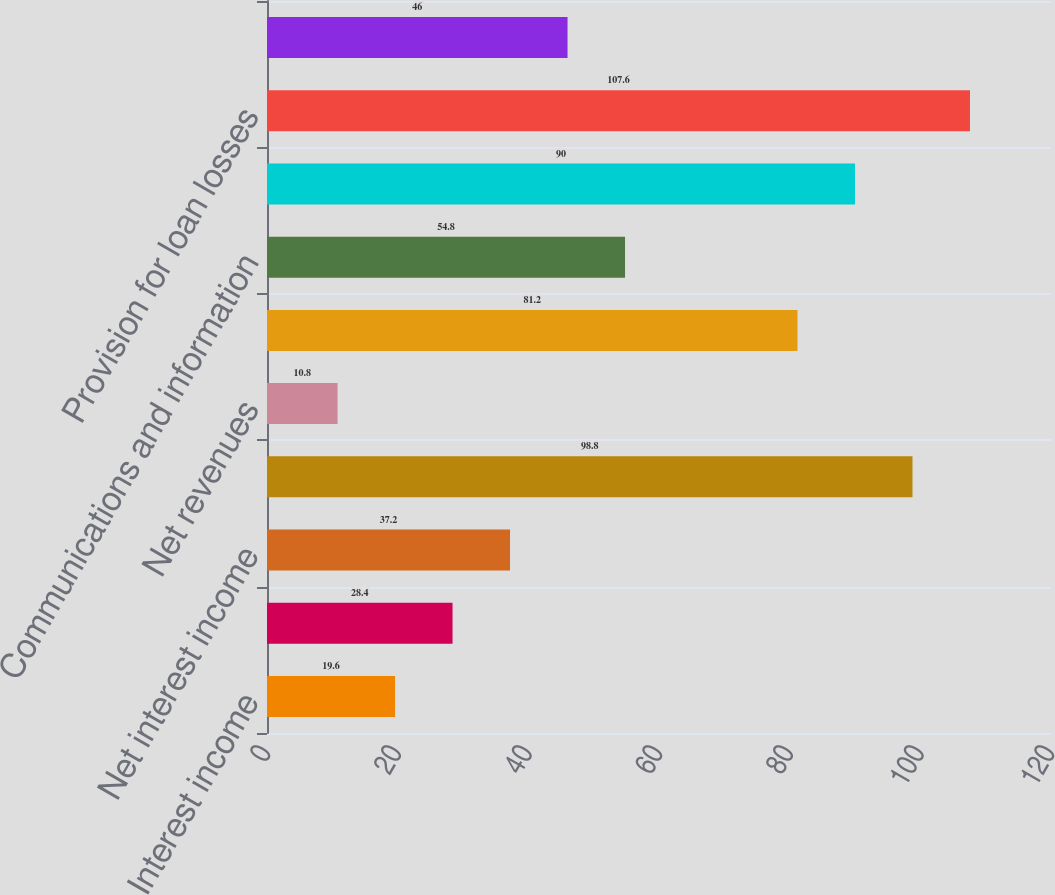<chart> <loc_0><loc_0><loc_500><loc_500><bar_chart><fcel>Interest income<fcel>Interest expense<fcel>Net interest income<fcel>Other income (loss)<fcel>Net revenues<fcel>Employee compensation and<fcel>Communications and information<fcel>Occupancy and equipment<fcel>Provision for loan losses<fcel>FDIC insurance premiums<nl><fcel>19.6<fcel>28.4<fcel>37.2<fcel>98.8<fcel>10.8<fcel>81.2<fcel>54.8<fcel>90<fcel>107.6<fcel>46<nl></chart> 